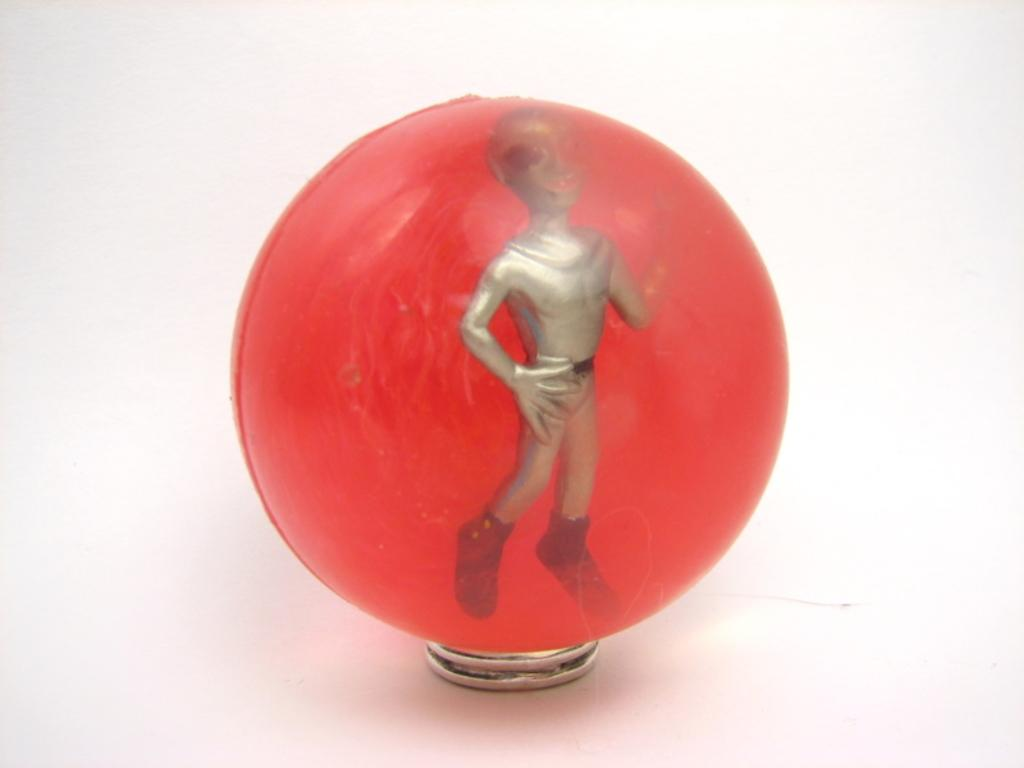What shape is the main object in the image? There is a sphere in the image. What can be found on or around the sphere? There are objects present on or around the sphere. How many pets are visible on the back of the sphere in the image? There are no pets visible on the sphere or its back in the image. 